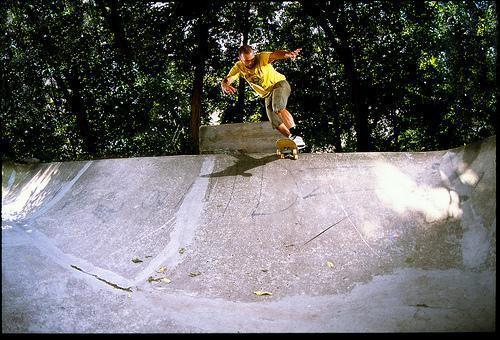How many people in the photo?
Give a very brief answer. 1. 